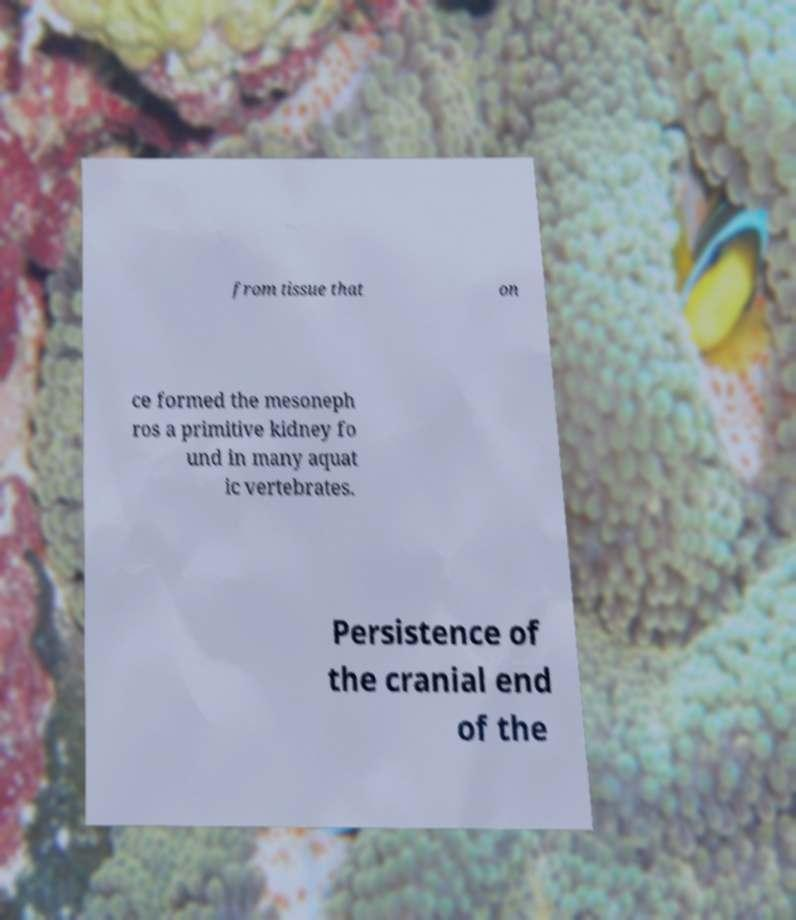Please read and relay the text visible in this image. What does it say? from tissue that on ce formed the mesoneph ros a primitive kidney fo und in many aquat ic vertebrates. Persistence of the cranial end of the 